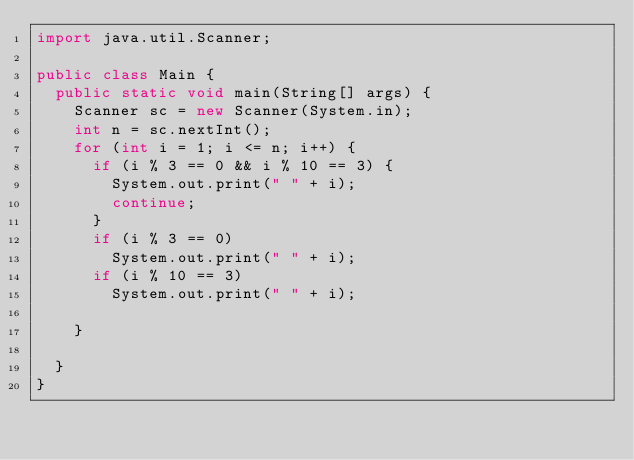<code> <loc_0><loc_0><loc_500><loc_500><_Java_>import java.util.Scanner;

public class Main {
	public static void main(String[] args) {
		Scanner sc = new Scanner(System.in);
		int n = sc.nextInt();
		for (int i = 1; i <= n; i++) {
			if (i % 3 == 0 && i % 10 == 3) {
				System.out.print(" " + i);
				continue;
			}
			if (i % 3 == 0)
				System.out.print(" " + i);
			if (i % 10 == 3)
				System.out.print(" " + i);

		}

	}
}</code> 